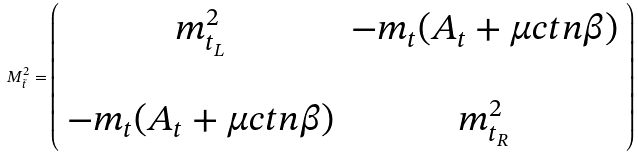Convert formula to latex. <formula><loc_0><loc_0><loc_500><loc_500>M _ { \tilde { t } } ^ { 2 } = \left ( \begin{array} { c c } m _ { t _ { L } } ^ { 2 } & - m _ { t } ( A _ { t } + \mu c t n \beta ) \\ \\ - m _ { t } ( A _ { t } + \mu c t n \beta ) & m _ { t _ { R } } ^ { 2 } \end{array} \right )</formula> 